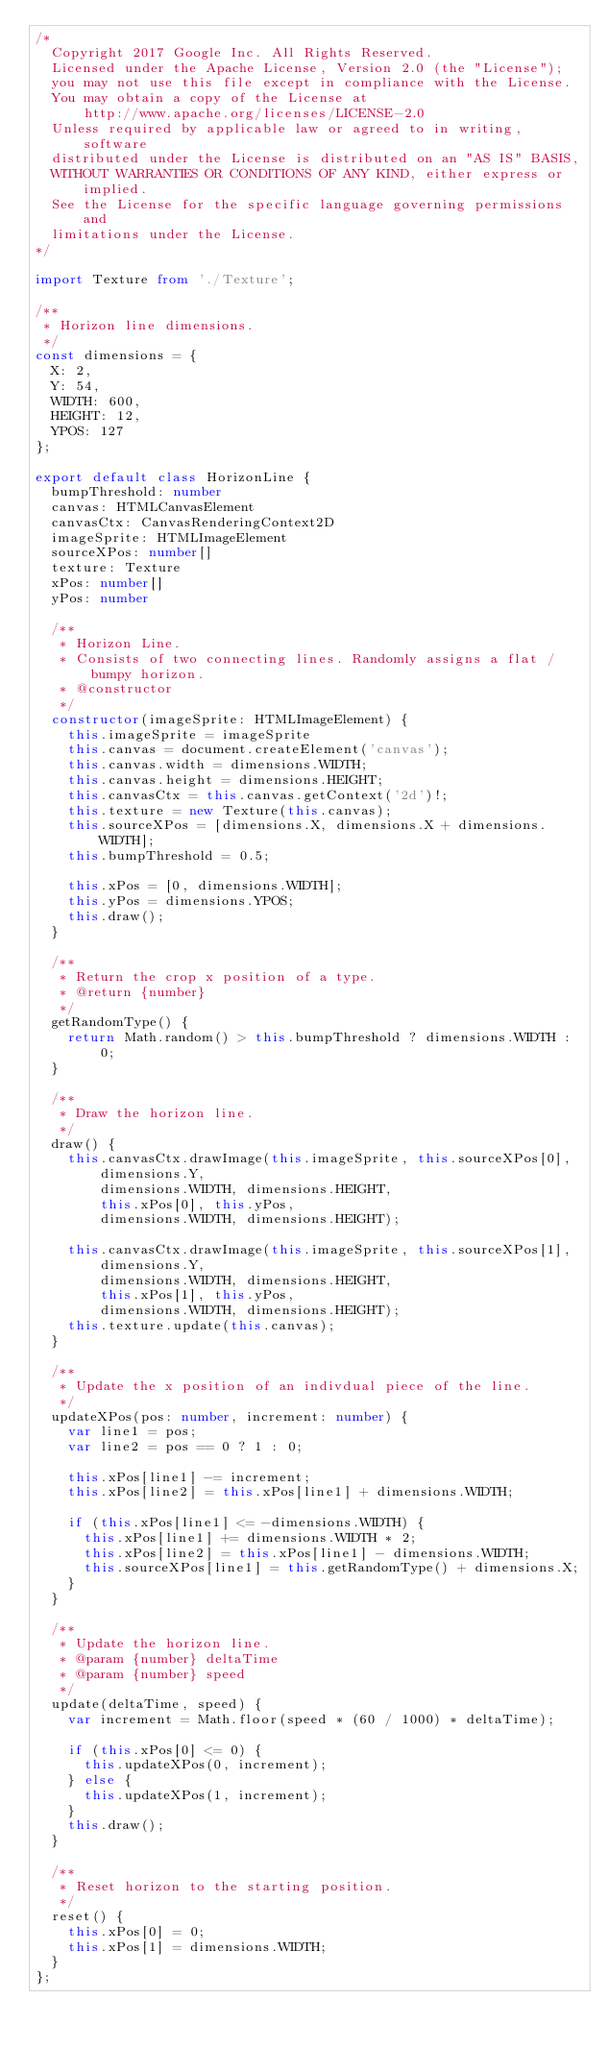Convert code to text. <code><loc_0><loc_0><loc_500><loc_500><_TypeScript_>/*
  Copyright 2017 Google Inc. All Rights Reserved.
  Licensed under the Apache License, Version 2.0 (the "License");
  you may not use this file except in compliance with the License.
  You may obtain a copy of the License at
      http://www.apache.org/licenses/LICENSE-2.0
  Unless required by applicable law or agreed to in writing, software
  distributed under the License is distributed on an "AS IS" BASIS,
  WITHOUT WARRANTIES OR CONDITIONS OF ANY KIND, either express or implied.
  See the License for the specific language governing permissions and
  limitations under the License.
*/

import Texture from './Texture';

/**
 * Horizon line dimensions.
 */
const dimensions = {
  X: 2,
  Y: 54,
  WIDTH: 600,
  HEIGHT: 12,
  YPOS: 127
};

export default class HorizonLine {
  bumpThreshold: number
  canvas: HTMLCanvasElement
  canvasCtx: CanvasRenderingContext2D
  imageSprite: HTMLImageElement
  sourceXPos: number[]
  texture: Texture
  xPos: number[]
  yPos: number

  /**
   * Horizon Line.
   * Consists of two connecting lines. Randomly assigns a flat / bumpy horizon.
   * @constructor
   */
  constructor(imageSprite: HTMLImageElement) {
    this.imageSprite = imageSprite
    this.canvas = document.createElement('canvas');
    this.canvas.width = dimensions.WIDTH;
    this.canvas.height = dimensions.HEIGHT;
    this.canvasCtx = this.canvas.getContext('2d')!;
    this.texture = new Texture(this.canvas);
    this.sourceXPos = [dimensions.X, dimensions.X + dimensions.WIDTH];
    this.bumpThreshold = 0.5;

    this.xPos = [0, dimensions.WIDTH];
    this.yPos = dimensions.YPOS;
    this.draw();
  }

  /**
   * Return the crop x position of a type.
   * @return {number}
   */
  getRandomType() {
    return Math.random() > this.bumpThreshold ? dimensions.WIDTH : 0;
  }

  /**
   * Draw the horizon line.
   */
  draw() {
    this.canvasCtx.drawImage(this.imageSprite, this.sourceXPos[0],
        dimensions.Y,
        dimensions.WIDTH, dimensions.HEIGHT,
        this.xPos[0], this.yPos,
        dimensions.WIDTH, dimensions.HEIGHT);

    this.canvasCtx.drawImage(this.imageSprite, this.sourceXPos[1],
        dimensions.Y,
        dimensions.WIDTH, dimensions.HEIGHT,
        this.xPos[1], this.yPos,
        dimensions.WIDTH, dimensions.HEIGHT);
    this.texture.update(this.canvas);
  }

  /**
   * Update the x position of an indivdual piece of the line.
   */
  updateXPos(pos: number, increment: number) {
    var line1 = pos;
    var line2 = pos == 0 ? 1 : 0;

    this.xPos[line1] -= increment;
    this.xPos[line2] = this.xPos[line1] + dimensions.WIDTH;

    if (this.xPos[line1] <= -dimensions.WIDTH) {
      this.xPos[line1] += dimensions.WIDTH * 2;
      this.xPos[line2] = this.xPos[line1] - dimensions.WIDTH;
      this.sourceXPos[line1] = this.getRandomType() + dimensions.X;
    }
  }

  /**
   * Update the horizon line.
   * @param {number} deltaTime
   * @param {number} speed
   */
  update(deltaTime, speed) {
    var increment = Math.floor(speed * (60 / 1000) * deltaTime);

    if (this.xPos[0] <= 0) {
      this.updateXPos(0, increment);
    } else {
      this.updateXPos(1, increment);
    }
    this.draw();
  }

  /**
   * Reset horizon to the starting position.
   */
  reset() {
    this.xPos[0] = 0;
    this.xPos[1] = dimensions.WIDTH;
  }
};

</code> 